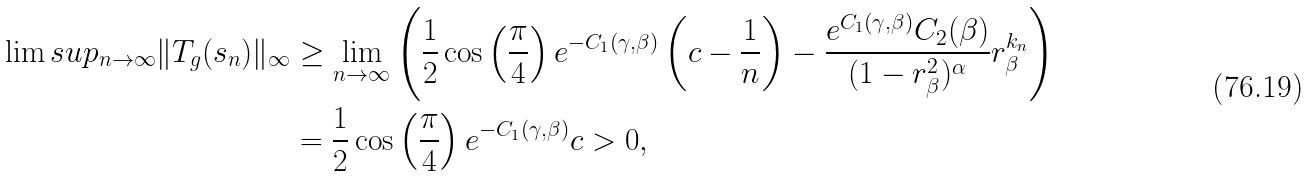Convert formula to latex. <formula><loc_0><loc_0><loc_500><loc_500>\lim s u p _ { n \to \infty } \| T _ { g } ( s _ { n } ) \| _ { \infty } & \geq \lim _ { n \to \infty } \left ( \frac { 1 } { 2 } \cos \left ( \frac { \pi } { 4 } \right ) e ^ { - C _ { 1 } ( \gamma , \beta ) } \left ( c - \frac { 1 } { n } \right ) - \frac { e ^ { C _ { 1 } ( \gamma , \beta ) } C _ { 2 } ( \beta ) } { ( 1 - r _ { \beta } ^ { 2 } ) ^ { \alpha } } r _ { \beta } ^ { k _ { n } } \right ) \\ & = \frac { 1 } { 2 } \cos \left ( \frac { \pi } { 4 } \right ) e ^ { - C _ { 1 } ( \gamma , \beta ) } c > 0 ,</formula> 